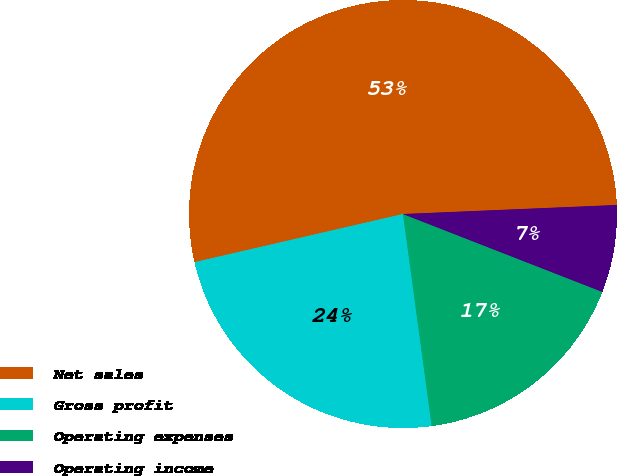Convert chart. <chart><loc_0><loc_0><loc_500><loc_500><pie_chart><fcel>Net sales<fcel>Gross profit<fcel>Operating expenses<fcel>Operating income<nl><fcel>52.94%<fcel>23.53%<fcel>16.93%<fcel>6.6%<nl></chart> 